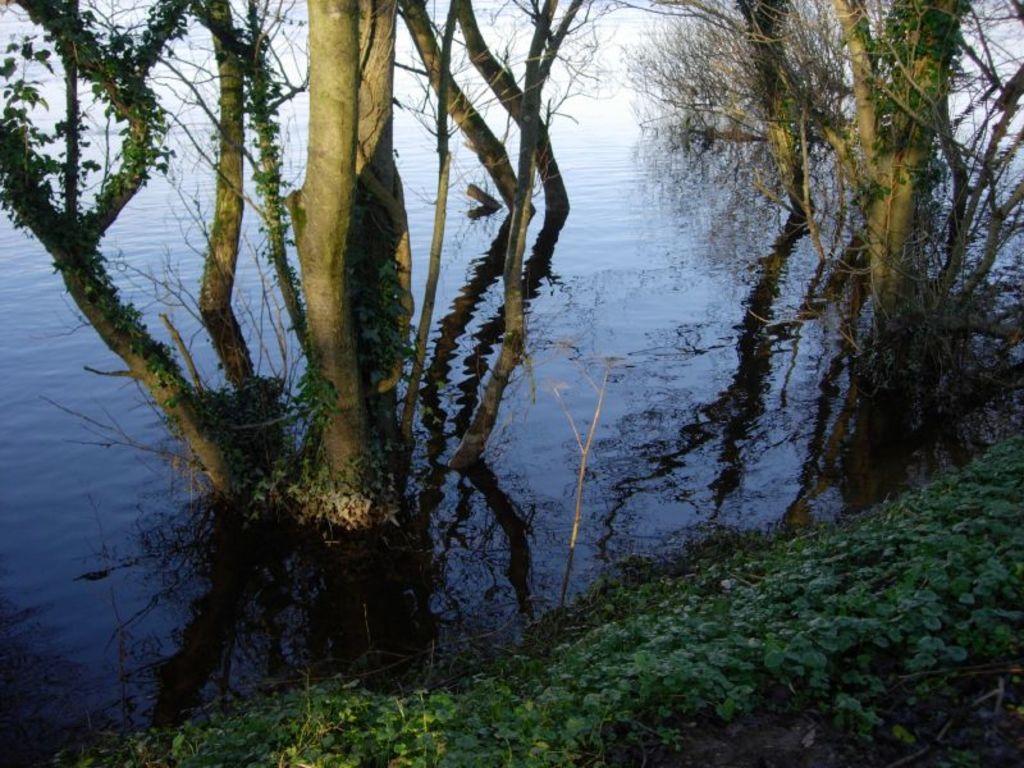Could you give a brief overview of what you see in this image? At the bottom there are plants. In the center of the picture there are trees and a water body. In the background there is water. 